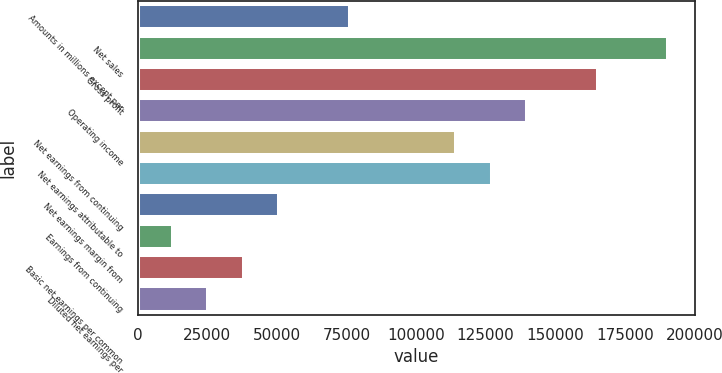<chart> <loc_0><loc_0><loc_500><loc_500><bar_chart><fcel>Amounts in millions except per<fcel>Net sales<fcel>Gross profit<fcel>Operating income<fcel>Net earnings from continuing<fcel>Net earnings attributable to<fcel>Net earnings margin from<fcel>Earnings from continuing<fcel>Basic net earnings per common<fcel>Diluted net earnings per<nl><fcel>76282.6<fcel>190703<fcel>165276<fcel>139849<fcel>114423<fcel>127136<fcel>50856<fcel>12716<fcel>38142.7<fcel>25429.3<nl></chart> 